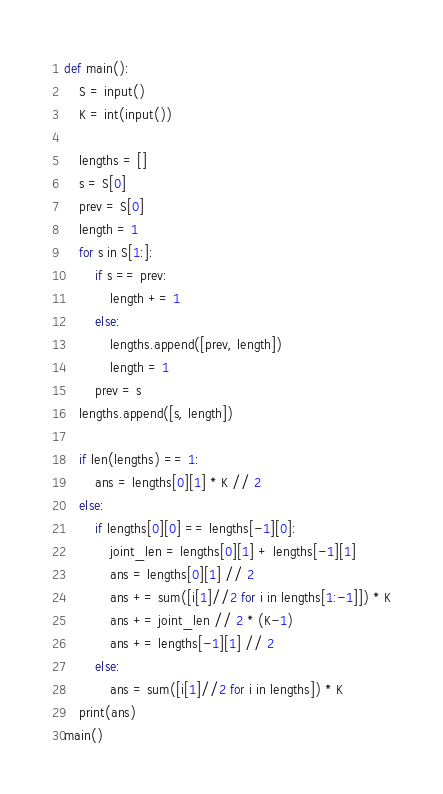Convert code to text. <code><loc_0><loc_0><loc_500><loc_500><_Python_>def main():
    S = input()
    K = int(input())
    
    lengths = []
    s = S[0]
    prev = S[0]
    length = 1
    for s in S[1:]:
        if s == prev:
            length += 1
        else:
            lengths.append([prev, length])
            length = 1
        prev = s
    lengths.append([s, length])

    if len(lengths) == 1:
        ans = lengths[0][1] * K // 2
    else:
        if lengths[0][0] == lengths[-1][0]:
            joint_len = lengths[0][1] + lengths[-1][1]
            ans = lengths[0][1] // 2
            ans += sum([i[1]//2 for i in lengths[1:-1]]) * K
            ans += joint_len // 2 * (K-1)
            ans += lengths[-1][1] // 2
        else:
            ans = sum([i[1]//2 for i in lengths]) * K
    print(ans)
main()</code> 